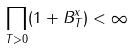Convert formula to latex. <formula><loc_0><loc_0><loc_500><loc_500>\prod _ { T > 0 } ( 1 + B _ { T } ^ { x } ) < \infty</formula> 